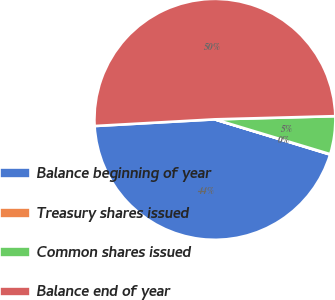<chart> <loc_0><loc_0><loc_500><loc_500><pie_chart><fcel>Balance beginning of year<fcel>Treasury shares issued<fcel>Common shares issued<fcel>Balance end of year<nl><fcel>44.4%<fcel>0.05%<fcel>5.09%<fcel>50.46%<nl></chart> 